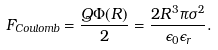<formula> <loc_0><loc_0><loc_500><loc_500>F _ { C o u l o m b } = \frac { Q \Phi ( R ) } { 2 } = \frac { 2 R ^ { 3 } \pi \sigma ^ { 2 } } { \epsilon _ { 0 } \epsilon _ { r } } .</formula> 